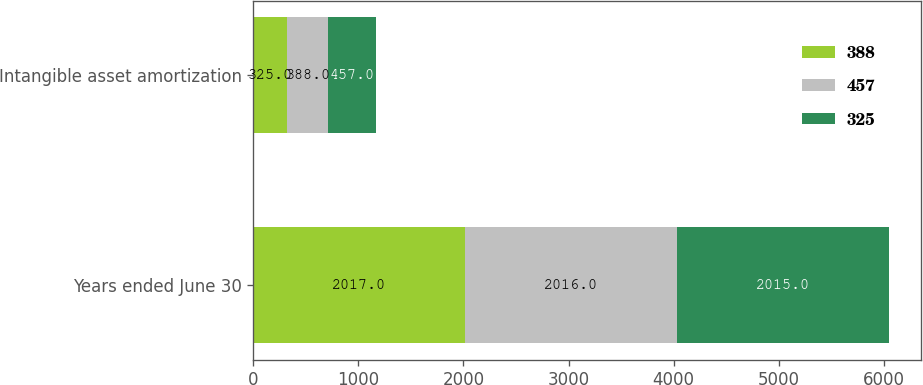<chart> <loc_0><loc_0><loc_500><loc_500><stacked_bar_chart><ecel><fcel>Years ended June 30<fcel>Intangible asset amortization<nl><fcel>388<fcel>2017<fcel>325<nl><fcel>457<fcel>2016<fcel>388<nl><fcel>325<fcel>2015<fcel>457<nl></chart> 